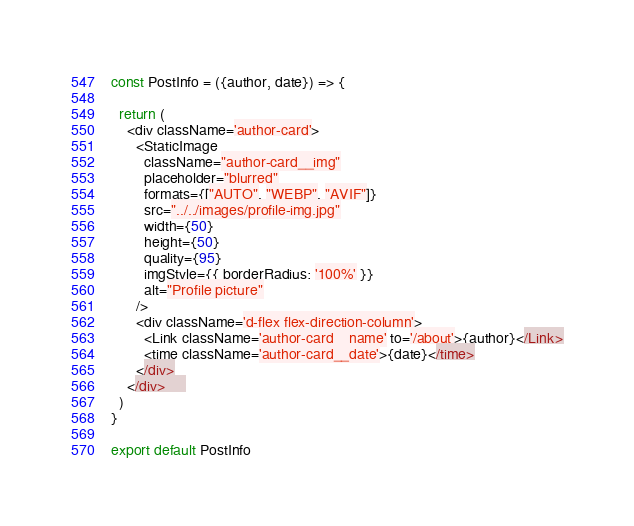<code> <loc_0><loc_0><loc_500><loc_500><_JavaScript_>

const PostInfo = ({author, date}) => {

  return (
    <div className='author-card'>
      <StaticImage
        className="author-card__img"
        placeholder="blurred"
        formats={["AUTO", "WEBP", "AVIF"]}
        src="../../images/profile-img.jpg"
        width={50}
        height={50}
        quality={95}
        imgStyle={{ borderRadius: '100%' }}
        alt="Profile picture"
      />
      <div className='d-flex flex-direction-column'>
        <Link className='author-card__name' to='/about'>{author}</Link>
        <time className='author-card__date'>{date}</time>
      </div>
    </div>     
  )
}

export default PostInfo
</code> 